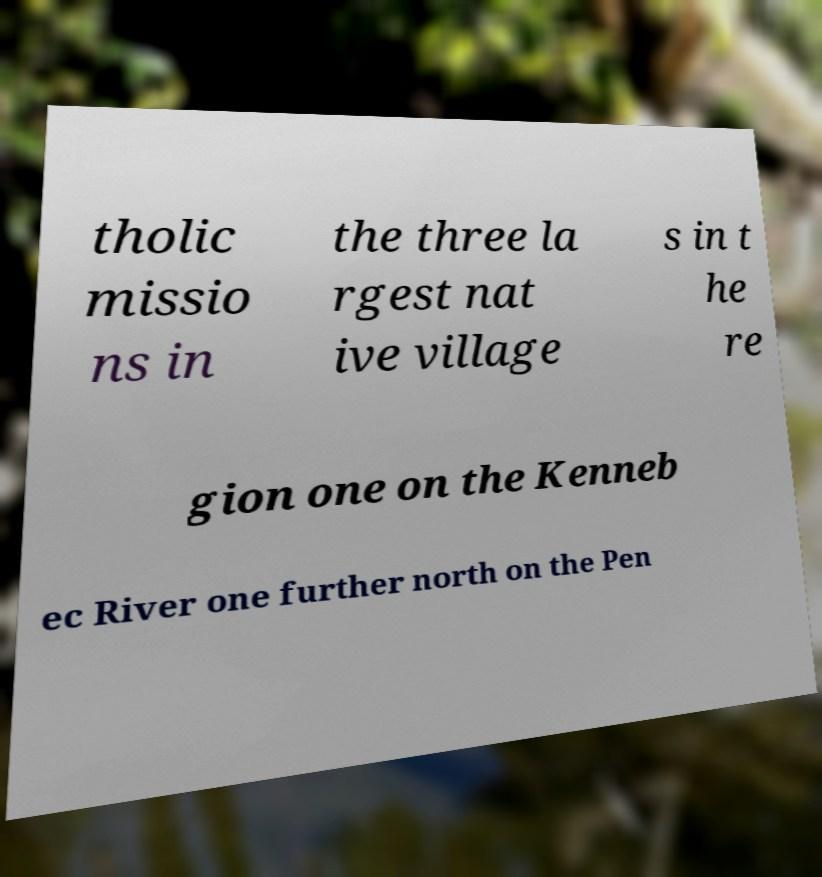Could you assist in decoding the text presented in this image and type it out clearly? tholic missio ns in the three la rgest nat ive village s in t he re gion one on the Kenneb ec River one further north on the Pen 